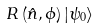<formula> <loc_0><loc_0><loc_500><loc_500>R \left ( { \hat { n } } , \phi \right ) \left | \psi _ { 0 } \right \rangle</formula> 